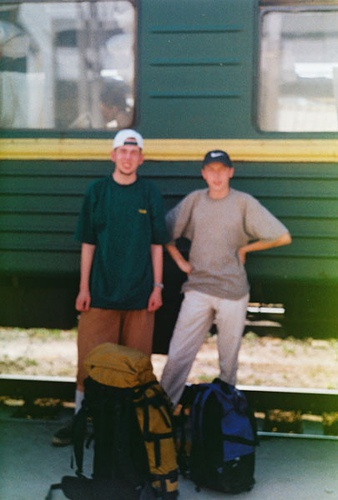Describe the objects in this image and their specific colors. I can see train in teal, black, and darkgray tones, people in teal, darkgray, gray, and black tones, people in teal, black, maroon, and brown tones, backpack in teal, black, maroon, and olive tones, and backpack in teal, black, navy, gray, and purple tones in this image. 